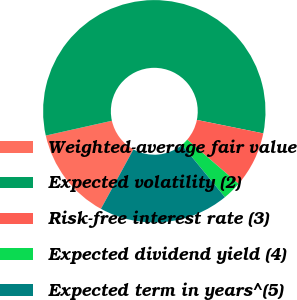Convert chart to OTSL. <chart><loc_0><loc_0><loc_500><loc_500><pie_chart><fcel>Weighted-average fair value<fcel>Expected volatility (2)<fcel>Risk-free interest rate (3)<fcel>Expected dividend yield (4)<fcel>Expected term in years^(5)<nl><fcel>13.53%<fcel>56.69%<fcel>8.13%<fcel>2.73%<fcel>18.92%<nl></chart> 